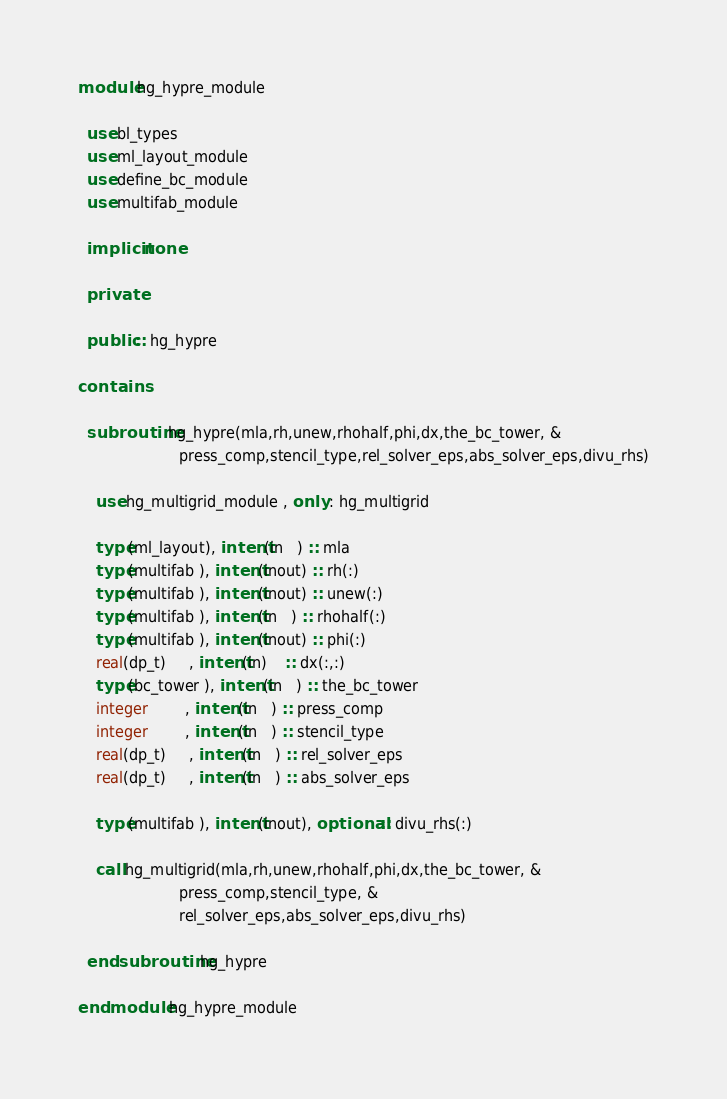<code> <loc_0><loc_0><loc_500><loc_500><_FORTRAN_>module hg_hypre_module
 
  use bl_types
  use ml_layout_module
  use define_bc_module
  use multifab_module
 
  implicit none
 
  private
 
  public :: hg_hypre

contains

  subroutine hg_hypre(mla,rh,unew,rhohalf,phi,dx,the_bc_tower, &
                      press_comp,stencil_type,rel_solver_eps,abs_solver_eps,divu_rhs)

    use hg_multigrid_module , only : hg_multigrid

    type(ml_layout), intent(in   ) :: mla
    type(multifab ), intent(inout) :: rh(:)
    type(multifab ), intent(inout) :: unew(:)
    type(multifab ), intent(in   ) :: rhohalf(:)
    type(multifab ), intent(inout) :: phi(:)
    real(dp_t)     , intent(in)    :: dx(:,:)
    type(bc_tower ), intent(in   ) :: the_bc_tower
    integer        , intent(in   ) :: press_comp
    integer        , intent(in   ) :: stencil_type
    real(dp_t)     , intent(in   ) :: rel_solver_eps
    real(dp_t)     , intent(in   ) :: abs_solver_eps

    type(multifab ), intent(inout), optional :: divu_rhs(:)

    call hg_multigrid(mla,rh,unew,rhohalf,phi,dx,the_bc_tower, &
                      press_comp,stencil_type, &
                      rel_solver_eps,abs_solver_eps,divu_rhs)

  end subroutine hg_hypre

end module hg_hypre_module
</code> 